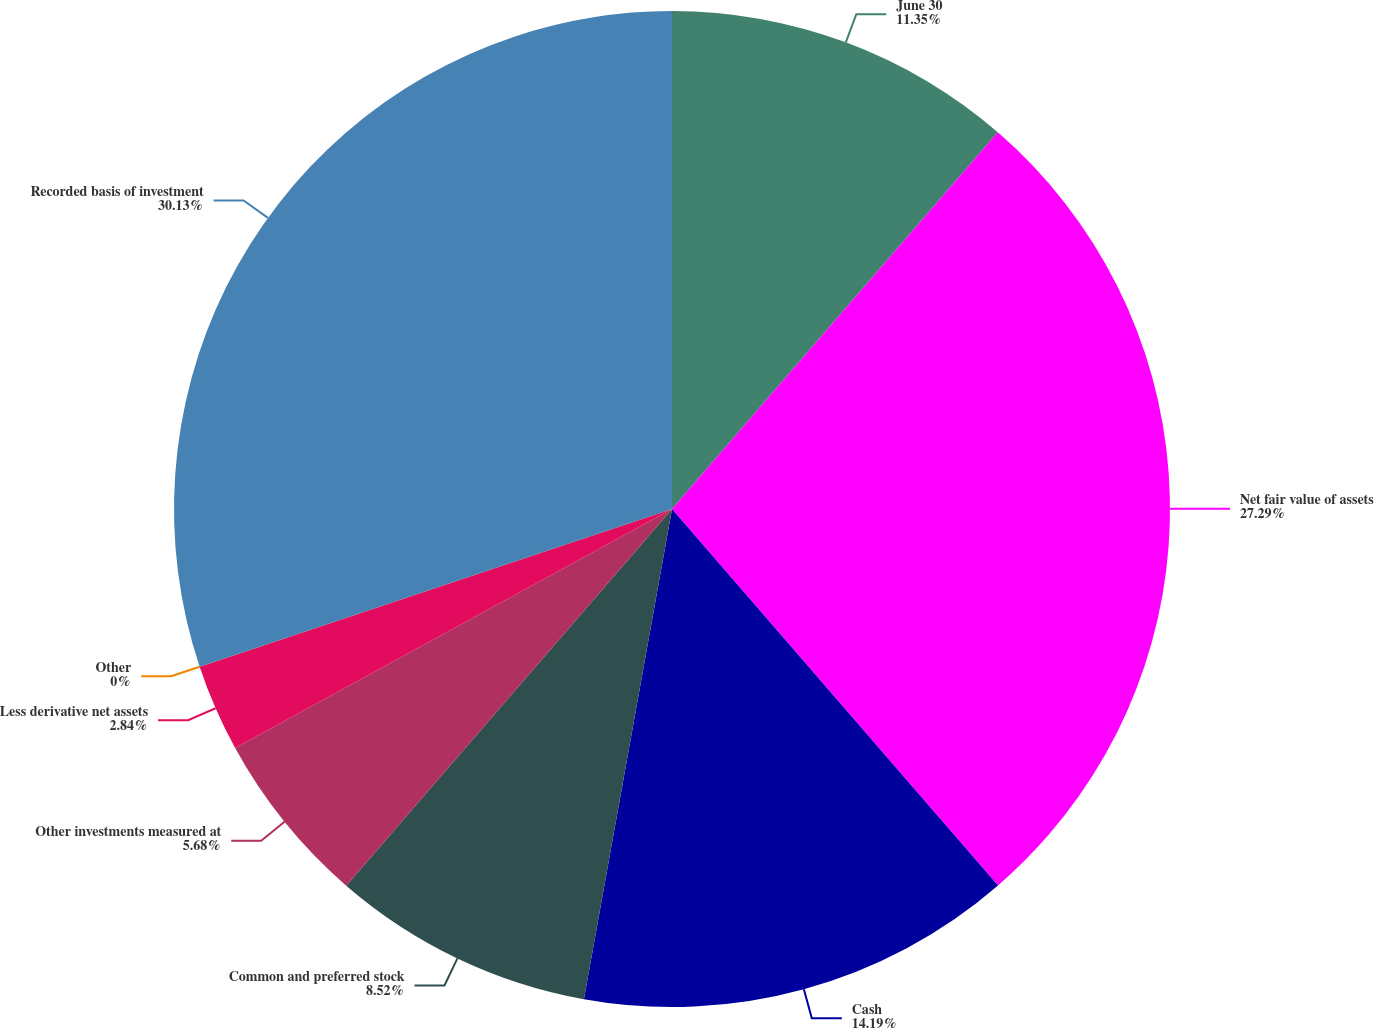<chart> <loc_0><loc_0><loc_500><loc_500><pie_chart><fcel>June 30<fcel>Net fair value of assets<fcel>Cash<fcel>Common and preferred stock<fcel>Other investments measured at<fcel>Less derivative net assets<fcel>Other<fcel>Recorded basis of investment<nl><fcel>11.35%<fcel>27.29%<fcel>14.19%<fcel>8.52%<fcel>5.68%<fcel>2.84%<fcel>0.0%<fcel>30.13%<nl></chart> 